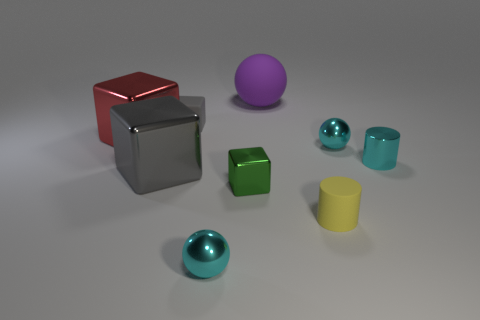There is a ball in front of the yellow cylinder; is it the same color as the metallic cylinder?
Your answer should be compact. Yes. Are there any other cyan things that have the same shape as the large matte thing?
Offer a very short reply. Yes. How big is the matte thing on the left side of the sphere that is in front of the sphere that is right of the large ball?
Your answer should be very brief. Small. There is a matte thing that is behind the small cyan cylinder and on the right side of the tiny matte block; what is its size?
Your answer should be compact. Large. Does the rubber cylinder on the left side of the tiny cyan cylinder have the same color as the cylinder behind the small yellow object?
Offer a terse response. No. There is a purple matte object; what number of small cyan shiny spheres are left of it?
Offer a very short reply. 1. Is there a small cyan cylinder in front of the cyan metallic object that is on the right side of the cyan shiny ball that is right of the large purple matte ball?
Your response must be concise. No. What number of red objects are the same size as the green cube?
Your answer should be compact. 0. What material is the block right of the tiny cyan sphere that is in front of the tiny shiny block?
Ensure brevity in your answer.  Metal. What is the shape of the cyan metallic thing that is in front of the matte object in front of the large metallic thing to the right of the large red metallic cube?
Your answer should be compact. Sphere. 